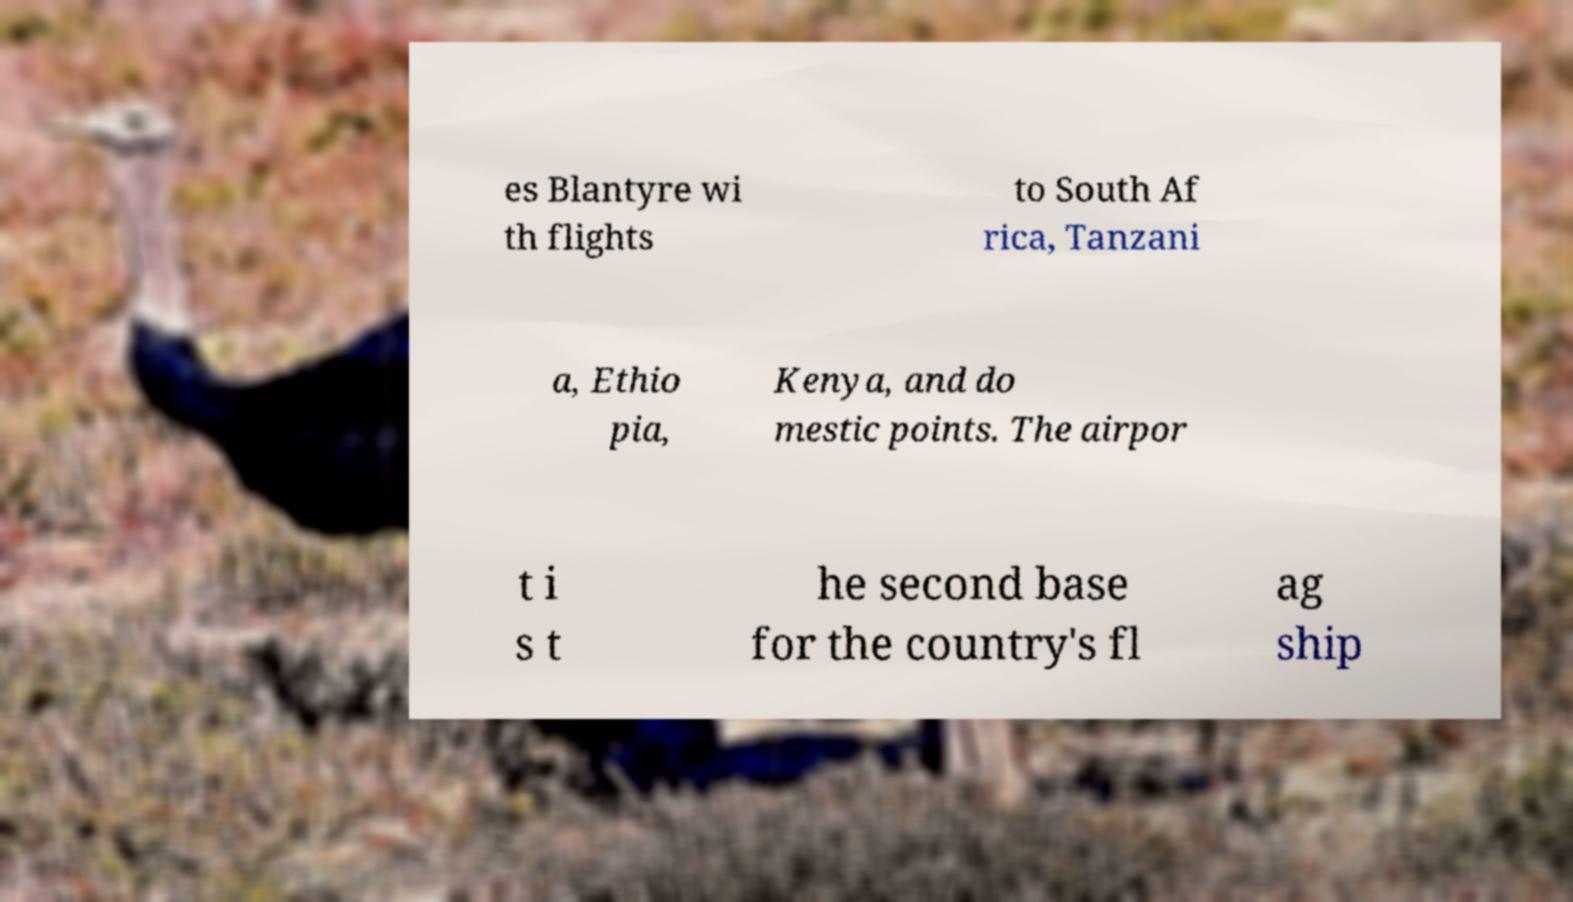Could you extract and type out the text from this image? es Blantyre wi th flights to South Af rica, Tanzani a, Ethio pia, Kenya, and do mestic points. The airpor t i s t he second base for the country's fl ag ship 